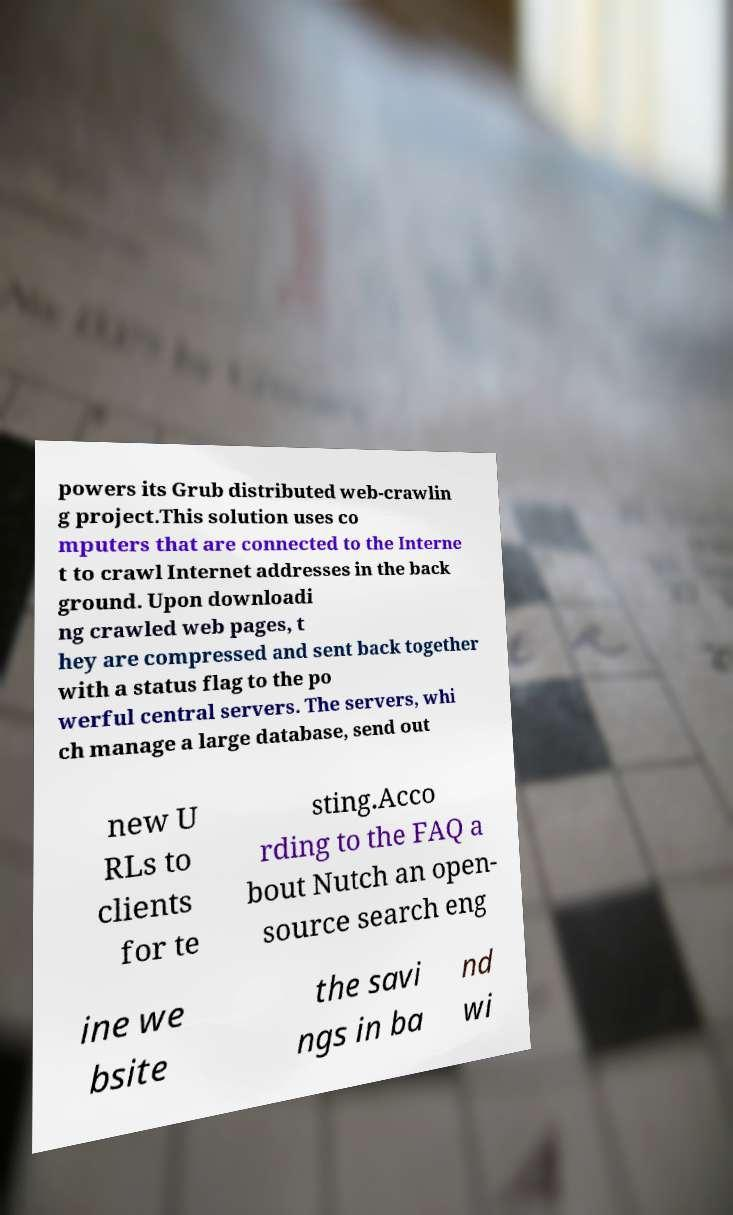Could you extract and type out the text from this image? powers its Grub distributed web-crawlin g project.This solution uses co mputers that are connected to the Interne t to crawl Internet addresses in the back ground. Upon downloadi ng crawled web pages, t hey are compressed and sent back together with a status flag to the po werful central servers. The servers, whi ch manage a large database, send out new U RLs to clients for te sting.Acco rding to the FAQ a bout Nutch an open- source search eng ine we bsite the savi ngs in ba nd wi 